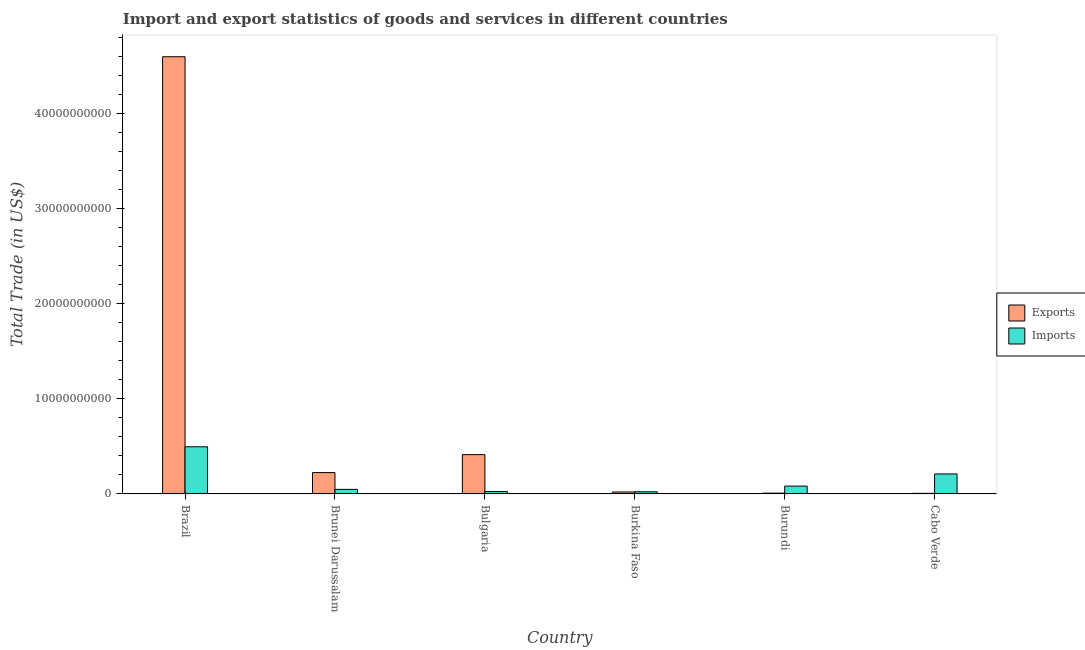Are the number of bars per tick equal to the number of legend labels?
Provide a succinct answer. Yes. What is the label of the 1st group of bars from the left?
Your answer should be very brief. Brazil. What is the imports of goods and services in Bulgaria?
Make the answer very short. 2.55e+08. Across all countries, what is the maximum imports of goods and services?
Your answer should be very brief. 4.96e+09. Across all countries, what is the minimum imports of goods and services?
Your answer should be compact. 2.31e+08. In which country was the export of goods and services minimum?
Give a very brief answer. Cabo Verde. What is the total export of goods and services in the graph?
Your answer should be compact. 5.27e+1. What is the difference between the export of goods and services in Burkina Faso and that in Cabo Verde?
Keep it short and to the point. 1.44e+08. What is the difference between the export of goods and services in Burundi and the imports of goods and services in Brazil?
Your answer should be compact. -4.88e+09. What is the average export of goods and services per country?
Offer a terse response. 8.79e+09. What is the difference between the imports of goods and services and export of goods and services in Burundi?
Your answer should be very brief. 7.40e+08. What is the ratio of the imports of goods and services in Bulgaria to that in Burkina Faso?
Provide a succinct answer. 1.1. What is the difference between the highest and the second highest export of goods and services?
Offer a very short reply. 4.18e+1. What is the difference between the highest and the lowest imports of goods and services?
Your answer should be compact. 4.73e+09. Is the sum of the export of goods and services in Brazil and Bulgaria greater than the maximum imports of goods and services across all countries?
Your answer should be very brief. Yes. What does the 1st bar from the left in Burundi represents?
Provide a succinct answer. Exports. What does the 2nd bar from the right in Brunei Darussalam represents?
Give a very brief answer. Exports. How many bars are there?
Your answer should be very brief. 12. Are all the bars in the graph horizontal?
Offer a very short reply. No. How many countries are there in the graph?
Your response must be concise. 6. Are the values on the major ticks of Y-axis written in scientific E-notation?
Offer a very short reply. No. Does the graph contain any zero values?
Your response must be concise. No. Where does the legend appear in the graph?
Your response must be concise. Center right. How many legend labels are there?
Provide a short and direct response. 2. What is the title of the graph?
Ensure brevity in your answer.  Import and export statistics of goods and services in different countries. What is the label or title of the X-axis?
Offer a very short reply. Country. What is the label or title of the Y-axis?
Your answer should be very brief. Total Trade (in US$). What is the Total Trade (in US$) of Exports in Brazil?
Keep it short and to the point. 4.60e+1. What is the Total Trade (in US$) of Imports in Brazil?
Your answer should be compact. 4.96e+09. What is the Total Trade (in US$) in Exports in Brunei Darussalam?
Offer a terse response. 2.25e+09. What is the Total Trade (in US$) in Imports in Brunei Darussalam?
Ensure brevity in your answer.  4.82e+08. What is the Total Trade (in US$) in Exports in Bulgaria?
Your answer should be compact. 4.14e+09. What is the Total Trade (in US$) of Imports in Bulgaria?
Provide a short and direct response. 2.55e+08. What is the Total Trade (in US$) of Exports in Burkina Faso?
Ensure brevity in your answer.  2.09e+08. What is the Total Trade (in US$) of Imports in Burkina Faso?
Offer a terse response. 2.31e+08. What is the Total Trade (in US$) of Exports in Burundi?
Provide a succinct answer. 8.81e+07. What is the Total Trade (in US$) in Imports in Burundi?
Keep it short and to the point. 8.28e+08. What is the Total Trade (in US$) of Exports in Cabo Verde?
Offer a terse response. 6.50e+07. What is the Total Trade (in US$) of Imports in Cabo Verde?
Provide a short and direct response. 2.11e+09. Across all countries, what is the maximum Total Trade (in US$) in Exports?
Keep it short and to the point. 4.60e+1. Across all countries, what is the maximum Total Trade (in US$) of Imports?
Your answer should be very brief. 4.96e+09. Across all countries, what is the minimum Total Trade (in US$) in Exports?
Provide a short and direct response. 6.50e+07. Across all countries, what is the minimum Total Trade (in US$) in Imports?
Keep it short and to the point. 2.31e+08. What is the total Total Trade (in US$) in Exports in the graph?
Provide a succinct answer. 5.27e+1. What is the total Total Trade (in US$) in Imports in the graph?
Give a very brief answer. 8.87e+09. What is the difference between the Total Trade (in US$) of Exports in Brazil and that in Brunei Darussalam?
Your answer should be very brief. 4.37e+1. What is the difference between the Total Trade (in US$) in Imports in Brazil and that in Brunei Darussalam?
Keep it short and to the point. 4.48e+09. What is the difference between the Total Trade (in US$) in Exports in Brazil and that in Bulgaria?
Give a very brief answer. 4.18e+1. What is the difference between the Total Trade (in US$) in Imports in Brazil and that in Bulgaria?
Your answer should be very brief. 4.71e+09. What is the difference between the Total Trade (in US$) in Exports in Brazil and that in Burkina Faso?
Your answer should be very brief. 4.58e+1. What is the difference between the Total Trade (in US$) of Imports in Brazil and that in Burkina Faso?
Ensure brevity in your answer.  4.73e+09. What is the difference between the Total Trade (in US$) of Exports in Brazil and that in Burundi?
Provide a succinct answer. 4.59e+1. What is the difference between the Total Trade (in US$) of Imports in Brazil and that in Burundi?
Make the answer very short. 4.14e+09. What is the difference between the Total Trade (in US$) of Exports in Brazil and that in Cabo Verde?
Ensure brevity in your answer.  4.59e+1. What is the difference between the Total Trade (in US$) of Imports in Brazil and that in Cabo Verde?
Your answer should be very brief. 2.86e+09. What is the difference between the Total Trade (in US$) of Exports in Brunei Darussalam and that in Bulgaria?
Give a very brief answer. -1.89e+09. What is the difference between the Total Trade (in US$) in Imports in Brunei Darussalam and that in Bulgaria?
Your answer should be very brief. 2.27e+08. What is the difference between the Total Trade (in US$) in Exports in Brunei Darussalam and that in Burkina Faso?
Your answer should be compact. 2.04e+09. What is the difference between the Total Trade (in US$) in Imports in Brunei Darussalam and that in Burkina Faso?
Your answer should be very brief. 2.51e+08. What is the difference between the Total Trade (in US$) in Exports in Brunei Darussalam and that in Burundi?
Your response must be concise. 2.16e+09. What is the difference between the Total Trade (in US$) of Imports in Brunei Darussalam and that in Burundi?
Offer a terse response. -3.46e+08. What is the difference between the Total Trade (in US$) in Exports in Brunei Darussalam and that in Cabo Verde?
Your answer should be very brief. 2.18e+09. What is the difference between the Total Trade (in US$) in Imports in Brunei Darussalam and that in Cabo Verde?
Make the answer very short. -1.62e+09. What is the difference between the Total Trade (in US$) in Exports in Bulgaria and that in Burkina Faso?
Provide a succinct answer. 3.93e+09. What is the difference between the Total Trade (in US$) of Imports in Bulgaria and that in Burkina Faso?
Your answer should be compact. 2.42e+07. What is the difference between the Total Trade (in US$) in Exports in Bulgaria and that in Burundi?
Your answer should be compact. 4.05e+09. What is the difference between the Total Trade (in US$) in Imports in Bulgaria and that in Burundi?
Offer a terse response. -5.73e+08. What is the difference between the Total Trade (in US$) in Exports in Bulgaria and that in Cabo Verde?
Your answer should be compact. 4.07e+09. What is the difference between the Total Trade (in US$) in Imports in Bulgaria and that in Cabo Verde?
Your answer should be compact. -1.85e+09. What is the difference between the Total Trade (in US$) of Exports in Burkina Faso and that in Burundi?
Make the answer very short. 1.21e+08. What is the difference between the Total Trade (in US$) of Imports in Burkina Faso and that in Burundi?
Offer a terse response. -5.97e+08. What is the difference between the Total Trade (in US$) in Exports in Burkina Faso and that in Cabo Verde?
Offer a very short reply. 1.44e+08. What is the difference between the Total Trade (in US$) of Imports in Burkina Faso and that in Cabo Verde?
Offer a terse response. -1.88e+09. What is the difference between the Total Trade (in US$) in Exports in Burundi and that in Cabo Verde?
Your answer should be compact. 2.30e+07. What is the difference between the Total Trade (in US$) of Imports in Burundi and that in Cabo Verde?
Offer a terse response. -1.28e+09. What is the difference between the Total Trade (in US$) in Exports in Brazil and the Total Trade (in US$) in Imports in Brunei Darussalam?
Offer a very short reply. 4.55e+1. What is the difference between the Total Trade (in US$) of Exports in Brazil and the Total Trade (in US$) of Imports in Bulgaria?
Ensure brevity in your answer.  4.57e+1. What is the difference between the Total Trade (in US$) of Exports in Brazil and the Total Trade (in US$) of Imports in Burkina Faso?
Give a very brief answer. 4.58e+1. What is the difference between the Total Trade (in US$) of Exports in Brazil and the Total Trade (in US$) of Imports in Burundi?
Your response must be concise. 4.52e+1. What is the difference between the Total Trade (in US$) in Exports in Brazil and the Total Trade (in US$) in Imports in Cabo Verde?
Ensure brevity in your answer.  4.39e+1. What is the difference between the Total Trade (in US$) in Exports in Brunei Darussalam and the Total Trade (in US$) in Imports in Bulgaria?
Ensure brevity in your answer.  1.99e+09. What is the difference between the Total Trade (in US$) of Exports in Brunei Darussalam and the Total Trade (in US$) of Imports in Burkina Faso?
Your answer should be compact. 2.02e+09. What is the difference between the Total Trade (in US$) in Exports in Brunei Darussalam and the Total Trade (in US$) in Imports in Burundi?
Provide a short and direct response. 1.42e+09. What is the difference between the Total Trade (in US$) in Exports in Brunei Darussalam and the Total Trade (in US$) in Imports in Cabo Verde?
Your answer should be compact. 1.42e+08. What is the difference between the Total Trade (in US$) of Exports in Bulgaria and the Total Trade (in US$) of Imports in Burkina Faso?
Make the answer very short. 3.91e+09. What is the difference between the Total Trade (in US$) of Exports in Bulgaria and the Total Trade (in US$) of Imports in Burundi?
Your answer should be very brief. 3.31e+09. What is the difference between the Total Trade (in US$) in Exports in Bulgaria and the Total Trade (in US$) in Imports in Cabo Verde?
Offer a terse response. 2.03e+09. What is the difference between the Total Trade (in US$) in Exports in Burkina Faso and the Total Trade (in US$) in Imports in Burundi?
Make the answer very short. -6.19e+08. What is the difference between the Total Trade (in US$) in Exports in Burkina Faso and the Total Trade (in US$) in Imports in Cabo Verde?
Provide a succinct answer. -1.90e+09. What is the difference between the Total Trade (in US$) in Exports in Burundi and the Total Trade (in US$) in Imports in Cabo Verde?
Give a very brief answer. -2.02e+09. What is the average Total Trade (in US$) of Exports per country?
Offer a very short reply. 8.79e+09. What is the average Total Trade (in US$) in Imports per country?
Your answer should be very brief. 1.48e+09. What is the difference between the Total Trade (in US$) in Exports and Total Trade (in US$) in Imports in Brazil?
Offer a very short reply. 4.10e+1. What is the difference between the Total Trade (in US$) in Exports and Total Trade (in US$) in Imports in Brunei Darussalam?
Keep it short and to the point. 1.77e+09. What is the difference between the Total Trade (in US$) in Exports and Total Trade (in US$) in Imports in Bulgaria?
Keep it short and to the point. 3.88e+09. What is the difference between the Total Trade (in US$) of Exports and Total Trade (in US$) of Imports in Burkina Faso?
Your answer should be very brief. -2.20e+07. What is the difference between the Total Trade (in US$) of Exports and Total Trade (in US$) of Imports in Burundi?
Offer a terse response. -7.40e+08. What is the difference between the Total Trade (in US$) of Exports and Total Trade (in US$) of Imports in Cabo Verde?
Keep it short and to the point. -2.04e+09. What is the ratio of the Total Trade (in US$) in Exports in Brazil to that in Brunei Darussalam?
Your answer should be very brief. 20.45. What is the ratio of the Total Trade (in US$) in Imports in Brazil to that in Brunei Darussalam?
Your answer should be compact. 10.3. What is the ratio of the Total Trade (in US$) in Exports in Brazil to that in Bulgaria?
Your answer should be compact. 11.11. What is the ratio of the Total Trade (in US$) in Imports in Brazil to that in Bulgaria?
Your response must be concise. 19.47. What is the ratio of the Total Trade (in US$) of Exports in Brazil to that in Burkina Faso?
Keep it short and to the point. 220.28. What is the ratio of the Total Trade (in US$) of Imports in Brazil to that in Burkina Faso?
Your answer should be compact. 21.51. What is the ratio of the Total Trade (in US$) of Exports in Brazil to that in Burundi?
Your response must be concise. 522.17. What is the ratio of the Total Trade (in US$) of Imports in Brazil to that in Burundi?
Keep it short and to the point. 6. What is the ratio of the Total Trade (in US$) in Exports in Brazil to that in Cabo Verde?
Your answer should be very brief. 707.07. What is the ratio of the Total Trade (in US$) in Imports in Brazil to that in Cabo Verde?
Offer a terse response. 2.36. What is the ratio of the Total Trade (in US$) of Exports in Brunei Darussalam to that in Bulgaria?
Ensure brevity in your answer.  0.54. What is the ratio of the Total Trade (in US$) of Imports in Brunei Darussalam to that in Bulgaria?
Your answer should be very brief. 1.89. What is the ratio of the Total Trade (in US$) in Exports in Brunei Darussalam to that in Burkina Faso?
Give a very brief answer. 10.77. What is the ratio of the Total Trade (in US$) in Imports in Brunei Darussalam to that in Burkina Faso?
Your answer should be very brief. 2.09. What is the ratio of the Total Trade (in US$) of Exports in Brunei Darussalam to that in Burundi?
Offer a terse response. 25.53. What is the ratio of the Total Trade (in US$) of Imports in Brunei Darussalam to that in Burundi?
Offer a terse response. 0.58. What is the ratio of the Total Trade (in US$) of Exports in Brunei Darussalam to that in Cabo Verde?
Your answer should be very brief. 34.57. What is the ratio of the Total Trade (in US$) of Imports in Brunei Darussalam to that in Cabo Verde?
Offer a very short reply. 0.23. What is the ratio of the Total Trade (in US$) in Exports in Bulgaria to that in Burkina Faso?
Your answer should be compact. 19.82. What is the ratio of the Total Trade (in US$) of Imports in Bulgaria to that in Burkina Faso?
Provide a short and direct response. 1.1. What is the ratio of the Total Trade (in US$) of Exports in Bulgaria to that in Burundi?
Give a very brief answer. 46.99. What is the ratio of the Total Trade (in US$) in Imports in Bulgaria to that in Burundi?
Provide a short and direct response. 0.31. What is the ratio of the Total Trade (in US$) of Exports in Bulgaria to that in Cabo Verde?
Offer a terse response. 63.62. What is the ratio of the Total Trade (in US$) in Imports in Bulgaria to that in Cabo Verde?
Make the answer very short. 0.12. What is the ratio of the Total Trade (in US$) in Exports in Burkina Faso to that in Burundi?
Offer a terse response. 2.37. What is the ratio of the Total Trade (in US$) of Imports in Burkina Faso to that in Burundi?
Your answer should be compact. 0.28. What is the ratio of the Total Trade (in US$) in Exports in Burkina Faso to that in Cabo Verde?
Your response must be concise. 3.21. What is the ratio of the Total Trade (in US$) of Imports in Burkina Faso to that in Cabo Verde?
Provide a short and direct response. 0.11. What is the ratio of the Total Trade (in US$) of Exports in Burundi to that in Cabo Verde?
Offer a very short reply. 1.35. What is the ratio of the Total Trade (in US$) in Imports in Burundi to that in Cabo Verde?
Offer a very short reply. 0.39. What is the difference between the highest and the second highest Total Trade (in US$) of Exports?
Your answer should be very brief. 4.18e+1. What is the difference between the highest and the second highest Total Trade (in US$) of Imports?
Make the answer very short. 2.86e+09. What is the difference between the highest and the lowest Total Trade (in US$) of Exports?
Provide a short and direct response. 4.59e+1. What is the difference between the highest and the lowest Total Trade (in US$) of Imports?
Your answer should be compact. 4.73e+09. 